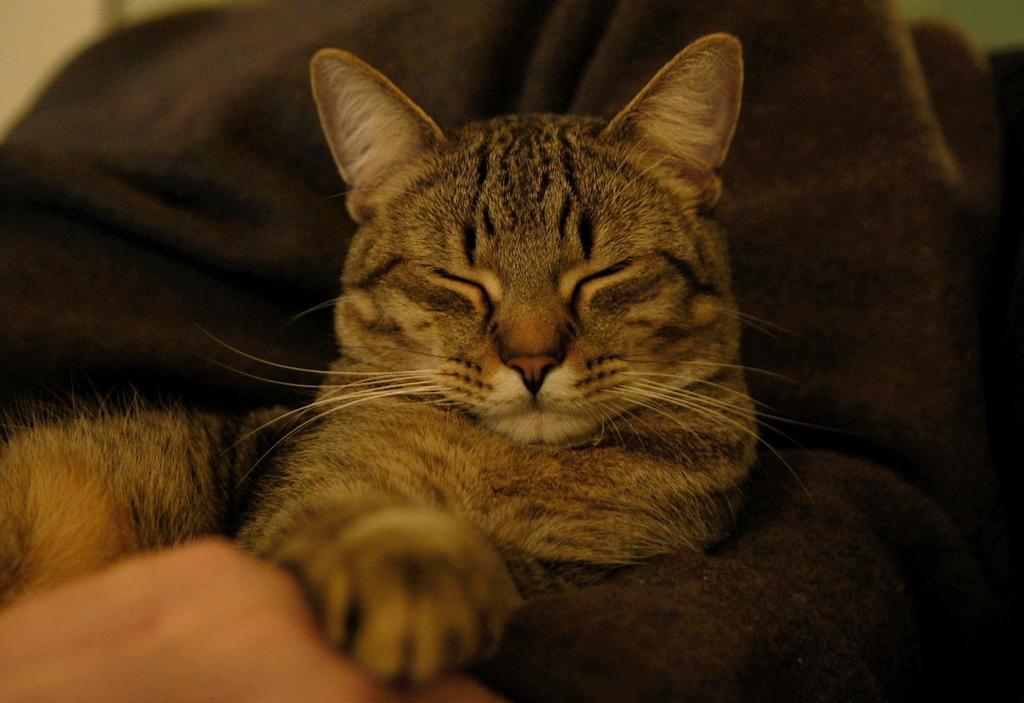Describe this image in one or two sentences. In this image we can see a cat on the sofa and in the background it looks like the wall. 